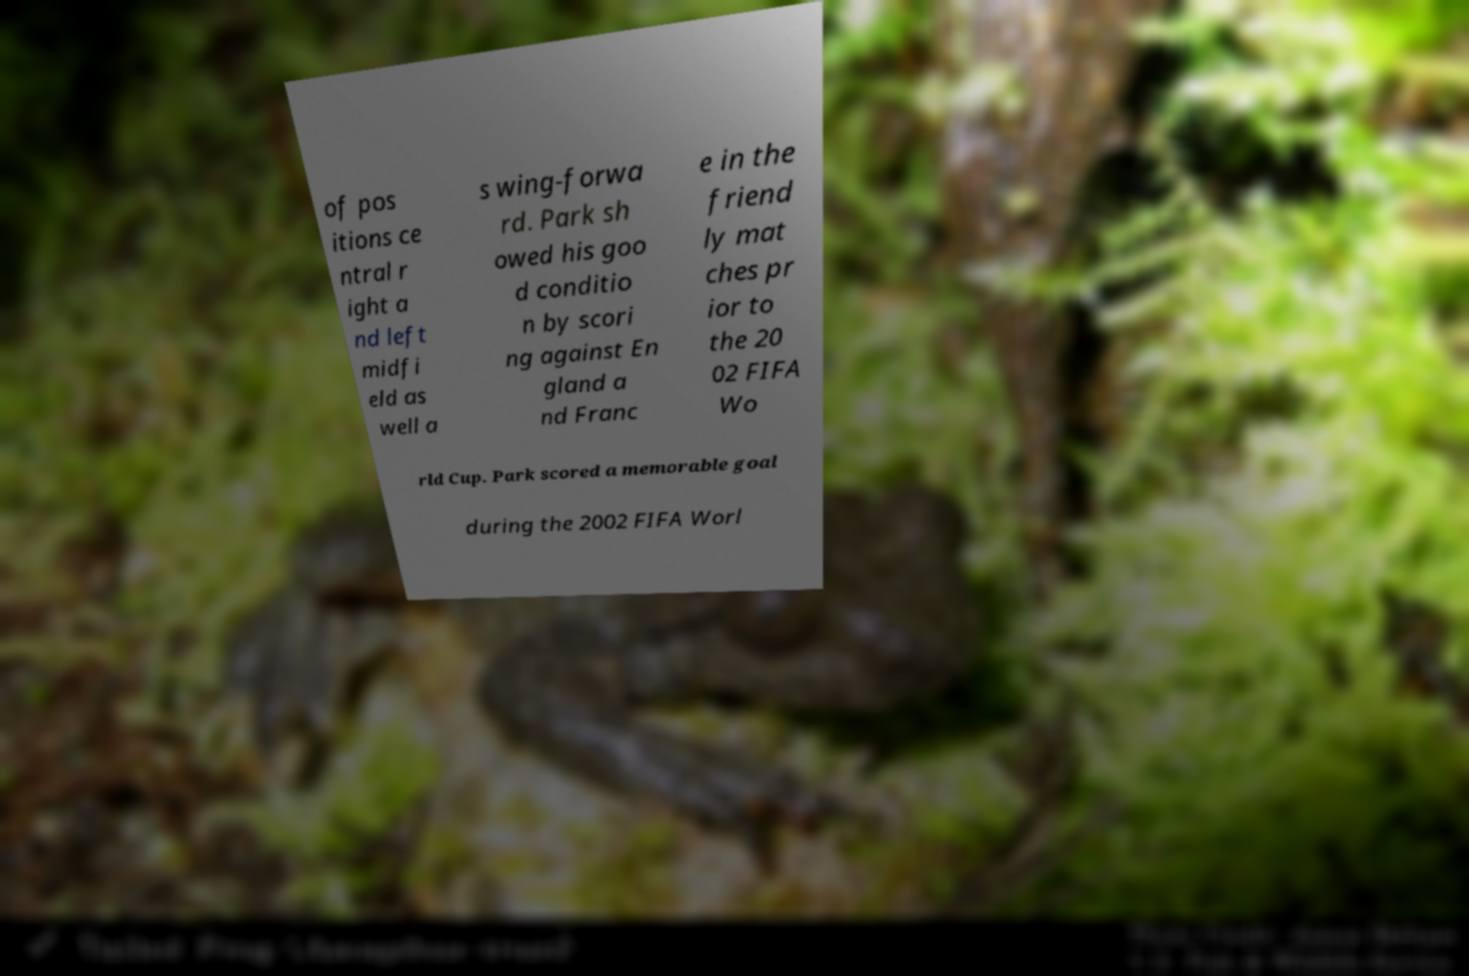Can you accurately transcribe the text from the provided image for me? of pos itions ce ntral r ight a nd left midfi eld as well a s wing-forwa rd. Park sh owed his goo d conditio n by scori ng against En gland a nd Franc e in the friend ly mat ches pr ior to the 20 02 FIFA Wo rld Cup. Park scored a memorable goal during the 2002 FIFA Worl 